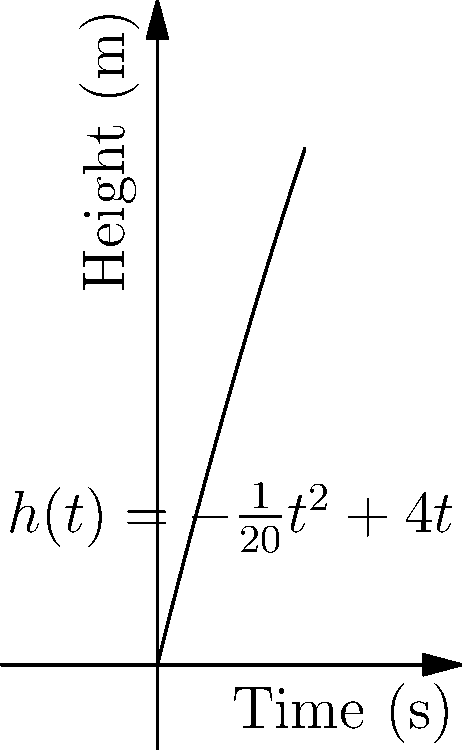A projectile is launched, and its height $h$ (in meters) as a function of time $t$ (in seconds) is given by the equation $h(t) = -\frac{1}{20}t^2 + 4t$. At what time does the projectile reach its maximum height, and what is the rate of change of its height at that moment? To solve this problem, we'll follow these steps:

1) First, we need to find the time when the projectile reaches its maximum height. This occurs when the rate of change of height with respect to time is zero.

2) The rate of change of height is given by the derivative of $h(t)$:

   $$\frac{dh}{dt} = -\frac{1}{10}t + 4$$

3) Set this equal to zero and solve for $t$:

   $$-\frac{1}{10}t + 4 = 0$$
   $$-\frac{1}{10}t = -4$$
   $$t = 40$$

4) So, the projectile reaches its maximum height at $t = 40$ seconds.

5) To find the rate of change at this moment, we could simply substitute $t = 40$ into the derivative we found earlier. However, we know that at the maximum height, the rate of change is zero.

Therefore, at the time of maximum height (40 seconds), the rate of change of the projectile's height is 0 m/s.
Answer: 40 seconds; 0 m/s 